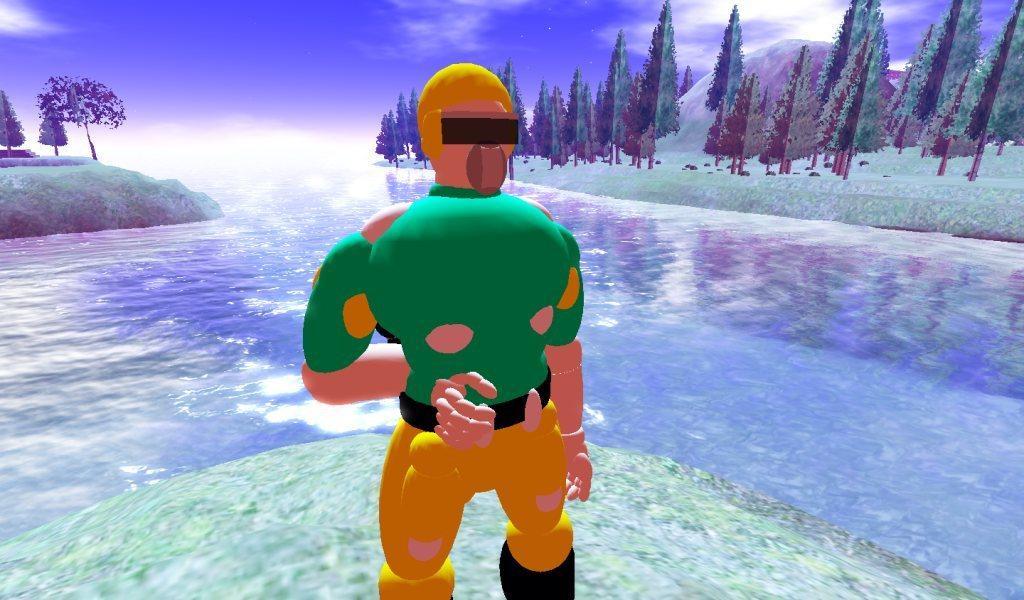Could you give a brief overview of what you see in this image? This is an animated image. In this image I can see the person, water and many trees. In the background I can see the clouds and the sky. 